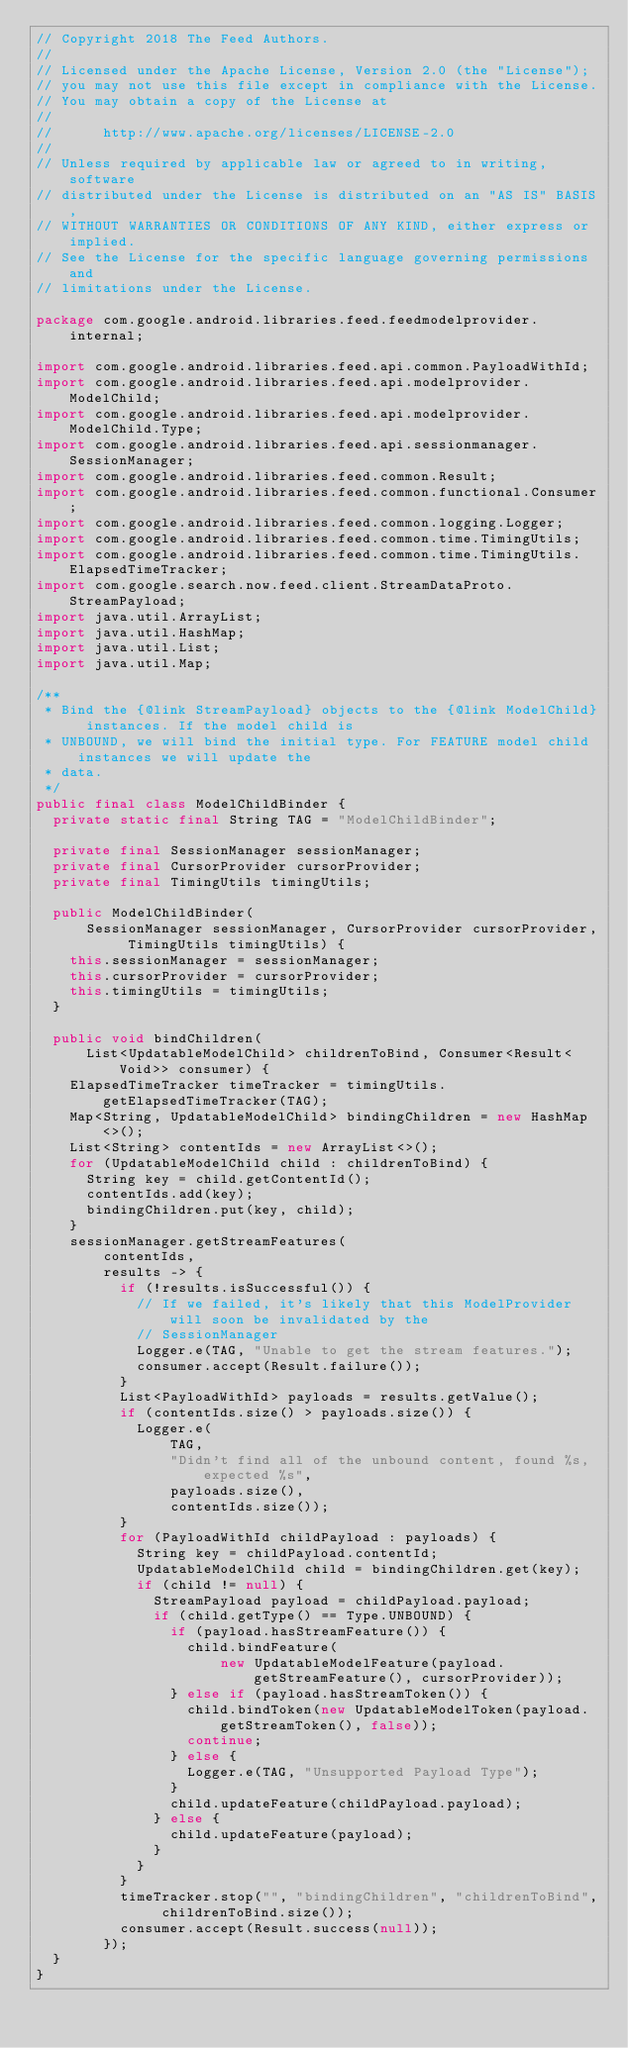<code> <loc_0><loc_0><loc_500><loc_500><_Java_>// Copyright 2018 The Feed Authors.
//
// Licensed under the Apache License, Version 2.0 (the "License");
// you may not use this file except in compliance with the License.
// You may obtain a copy of the License at
//
//      http://www.apache.org/licenses/LICENSE-2.0
//
// Unless required by applicable law or agreed to in writing, software
// distributed under the License is distributed on an "AS IS" BASIS,
// WITHOUT WARRANTIES OR CONDITIONS OF ANY KIND, either express or implied.
// See the License for the specific language governing permissions and
// limitations under the License.

package com.google.android.libraries.feed.feedmodelprovider.internal;

import com.google.android.libraries.feed.api.common.PayloadWithId;
import com.google.android.libraries.feed.api.modelprovider.ModelChild;
import com.google.android.libraries.feed.api.modelprovider.ModelChild.Type;
import com.google.android.libraries.feed.api.sessionmanager.SessionManager;
import com.google.android.libraries.feed.common.Result;
import com.google.android.libraries.feed.common.functional.Consumer;
import com.google.android.libraries.feed.common.logging.Logger;
import com.google.android.libraries.feed.common.time.TimingUtils;
import com.google.android.libraries.feed.common.time.TimingUtils.ElapsedTimeTracker;
import com.google.search.now.feed.client.StreamDataProto.StreamPayload;
import java.util.ArrayList;
import java.util.HashMap;
import java.util.List;
import java.util.Map;

/**
 * Bind the {@link StreamPayload} objects to the {@link ModelChild} instances. If the model child is
 * UNBOUND, we will bind the initial type. For FEATURE model child instances we will update the
 * data.
 */
public final class ModelChildBinder {
  private static final String TAG = "ModelChildBinder";

  private final SessionManager sessionManager;
  private final CursorProvider cursorProvider;
  private final TimingUtils timingUtils;

  public ModelChildBinder(
      SessionManager sessionManager, CursorProvider cursorProvider, TimingUtils timingUtils) {
    this.sessionManager = sessionManager;
    this.cursorProvider = cursorProvider;
    this.timingUtils = timingUtils;
  }

  public void bindChildren(
      List<UpdatableModelChild> childrenToBind, Consumer<Result<Void>> consumer) {
    ElapsedTimeTracker timeTracker = timingUtils.getElapsedTimeTracker(TAG);
    Map<String, UpdatableModelChild> bindingChildren = new HashMap<>();
    List<String> contentIds = new ArrayList<>();
    for (UpdatableModelChild child : childrenToBind) {
      String key = child.getContentId();
      contentIds.add(key);
      bindingChildren.put(key, child);
    }
    sessionManager.getStreamFeatures(
        contentIds,
        results -> {
          if (!results.isSuccessful()) {
            // If we failed, it's likely that this ModelProvider will soon be invalidated by the
            // SessionManager
            Logger.e(TAG, "Unable to get the stream features.");
            consumer.accept(Result.failure());
          }
          List<PayloadWithId> payloads = results.getValue();
          if (contentIds.size() > payloads.size()) {
            Logger.e(
                TAG,
                "Didn't find all of the unbound content, found %s, expected %s",
                payloads.size(),
                contentIds.size());
          }
          for (PayloadWithId childPayload : payloads) {
            String key = childPayload.contentId;
            UpdatableModelChild child = bindingChildren.get(key);
            if (child != null) {
              StreamPayload payload = childPayload.payload;
              if (child.getType() == Type.UNBOUND) {
                if (payload.hasStreamFeature()) {
                  child.bindFeature(
                      new UpdatableModelFeature(payload.getStreamFeature(), cursorProvider));
                } else if (payload.hasStreamToken()) {
                  child.bindToken(new UpdatableModelToken(payload.getStreamToken(), false));
                  continue;
                } else {
                  Logger.e(TAG, "Unsupported Payload Type");
                }
                child.updateFeature(childPayload.payload);
              } else {
                child.updateFeature(payload);
              }
            }
          }
          timeTracker.stop("", "bindingChildren", "childrenToBind", childrenToBind.size());
          consumer.accept(Result.success(null));
        });
  }
}
</code> 